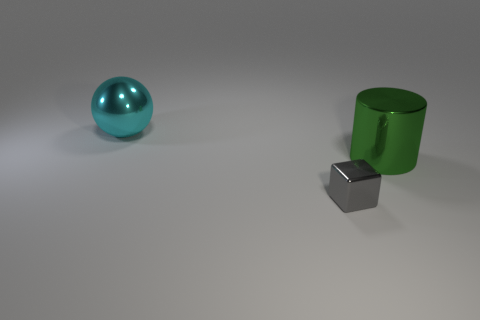Add 1 big rubber cylinders. How many objects exist? 4 Subtract all cylinders. How many objects are left? 2 Subtract all cylinders. Subtract all tiny green objects. How many objects are left? 2 Add 3 large green cylinders. How many large green cylinders are left? 4 Add 2 big cyan metallic things. How many big cyan metallic things exist? 3 Subtract 0 yellow spheres. How many objects are left? 3 